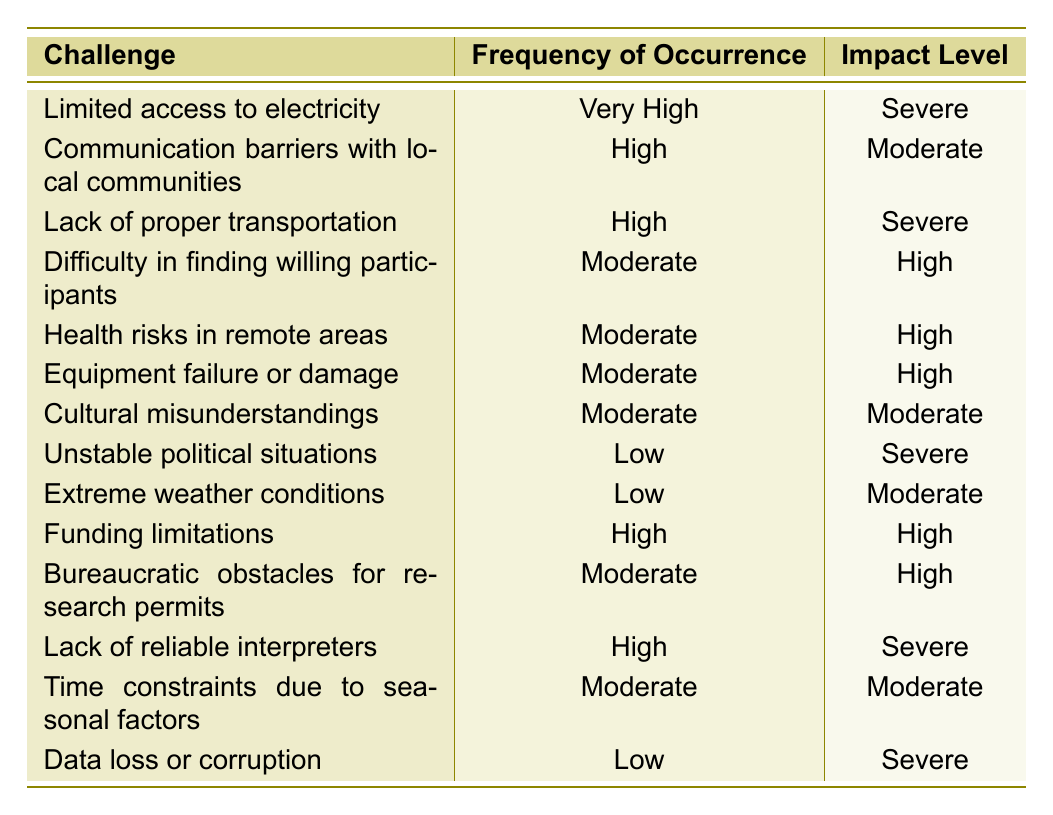What is the challenge with the highest frequency of occurrence? The table lists various challenges and their corresponding frequencies. Scanning down the "Frequency of Occurrence" column, "Very High" is assigned to "Limited access to electricity."
Answer: Limited access to electricity How many challenges have a high frequency of occurrence? By counting the entries under "Frequency of Occurrence," there are three challenges marked as "High," which are "Communication barriers with local communities," "Lack of proper transportation," and "Funding limitations."
Answer: Three What is the impact level of "Health risks in remote areas"? Looking at the "Impact Level" column, the row for "Health risks in remote areas" shows that the impact level is marked as "High."
Answer: High Are there any challenges listed with a "Low" frequency of occurrence? Yes, by inspecting the "Frequency of Occurrence" column, two challenges - "Unstable political situations," "Extreme weather conditions," and "Data loss or corruption" are marked as "Low."
Answer: Yes What is the difference in impact level between the challenges with "Very High" and "Low" frequency? "Limited access to electricity" with a "Very High" frequency has a "Severe" impact. In contrast, challenges with "Low" frequency such as "Unstable political situations," "Extreme weather conditions," and "Data loss or corruption" have a "Severe" and "Moderate" impact. Thus, the difference would be between "Severe" and either "Severe" or "Moderate."
Answer: No difference; severe impact What percentage of challenges have a severe impact level? In the table, challenges with severe impact are "Limited access to electricity," "Lack of proper transportation," "Unstable political situations," "Lack of reliable interpreters," and "Data loss or corruption." There are 5 severe challenges out of 14 total challenges. Therefore, the percentage is (5/14) * 100 ≈ 35.71%.
Answer: Approximately 35.71% How does the frequency of "Lack of reliable interpreters" compare to "Funding limitations"? Both "Lack of reliable interpreters" and "Funding limitations" are denoted as having "High" frequency. Thus, they are equivalent in this regard.
Answer: They are equal Which challenges have a moderate impact but do not have high frequency of occurrence? Referring to the table, "Cultural misunderstandings" and "Time constraints due to seasonal factors" are marked with "Moderate" impact but have "Moderate" frequency instead of "High."
Answer: Cultural misunderstandings, Time constraints due to seasonal factors Identify the challenge with the lowest frequency of occurrence and indicate its impact level. The challenge with "Low" frequency of occurrence is "Data loss or corruption," which is shown to have a "Severe" impact level according to the table.
Answer: Severe What is the total number of challenges that are categorized as having a "Moderate" impact level? From the table, the challenges with a "Moderate" impact level are "Difficulty in finding willing participants," "Health risks in remote areas," "Equipment failure or damage," "Cultural misunderstandings," "Bureaucratic obstacles for research permits," and "Time constraints due to seasonal factors." Counting these gives a total of 6 challenges.
Answer: Six Which challenge categorized as "High" frequency has the most severe impact? The challenges categorized as "High" frequency include "Communication barriers with local communities," "Lack of proper transportation," "Funding limitations," and "Lack of reliable interpreters." Among them, "Lack of proper transportation" and "Lack of reliable interpreters" hold the "Severe" impact level. The answer to the question is "Lack of proper transportation."
Answer: Lack of proper transportation 